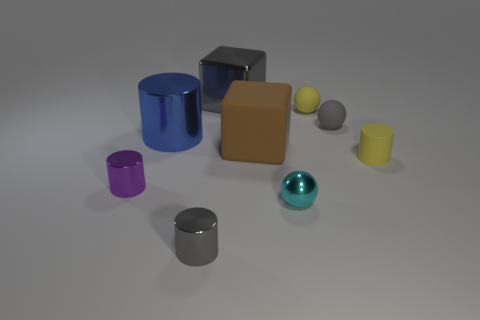What is the color of the tiny sphere that is the same material as the large gray cube?
Your answer should be very brief. Cyan. Is the number of purple spheres less than the number of brown blocks?
Offer a terse response. Yes. Is the shape of the yellow matte thing behind the rubber block the same as the gray metallic thing in front of the tiny rubber cylinder?
Provide a short and direct response. No. What number of objects are either brown blocks or shiny spheres?
Ensure brevity in your answer.  2. There is a rubber cylinder that is the same size as the cyan sphere; what color is it?
Give a very brief answer. Yellow. There is a big brown matte object that is on the right side of the large metal cylinder; what number of cyan things are behind it?
Provide a succinct answer. 0. How many tiny things are behind the blue object and in front of the tiny gray matte sphere?
Your response must be concise. 0. What number of objects are gray objects in front of the tiny cyan shiny sphere or large cubes that are on the left side of the big matte thing?
Give a very brief answer. 2. How many other objects are there of the same size as the yellow sphere?
Make the answer very short. 5. There is a small metal thing that is in front of the metallic thing to the right of the big gray object; what is its shape?
Your answer should be very brief. Cylinder. 